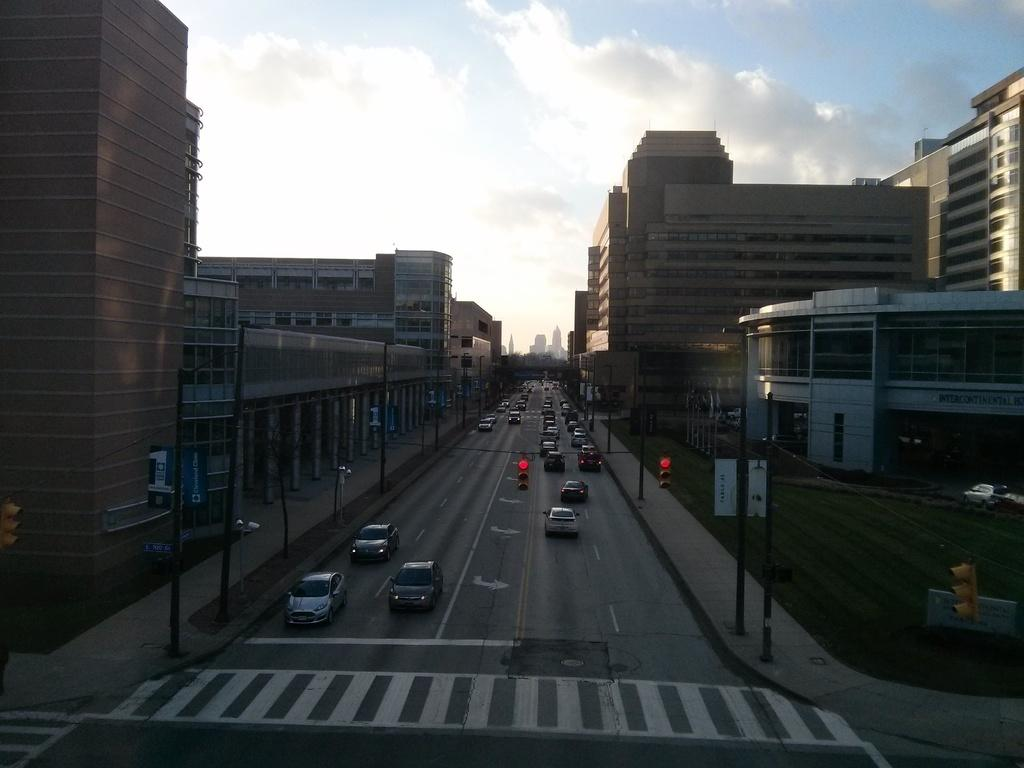What is happening on the road in the image? There are vehicles moving on the road in the image. What helps regulate the traffic in the image? Traffic signals are present in the image. What structures can be seen supporting wires or other objects in the image? Poles are visible in the image. What type of signage or advertisements can be seen in the image? Boards are present in the image. What type of structures are present on either side of the road in the image? Buildings are present on either side of the road in the image. What can be seen in the background of the image? The sky is visible in the background of the image, and clouds are present in the sky. How many mice are running across the road in the image? There are no mice present in the image; it features vehicles moving on the road. What type of pin is holding the traffic signal in place in the image? There is no pin holding the traffic signal in place in the image; it is attached to a pole. 